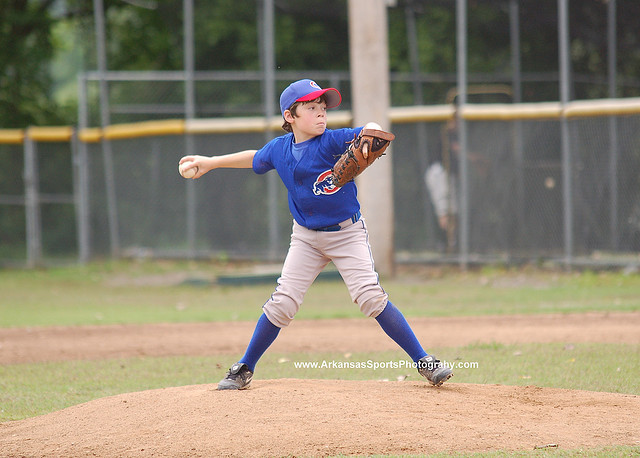<image>What position does this kid play? I am not sure about the position this kid plays. It might be a pitcher or a catcher. What position does this kid play? I don't know what position this kid plays. It can be seen as a pitcher or catcher. 